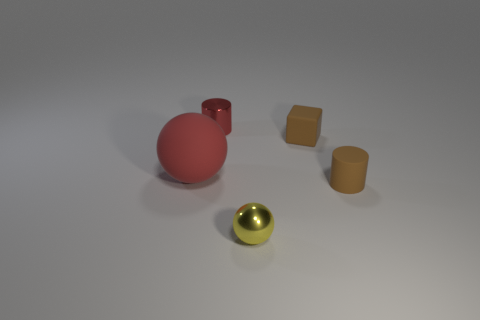Do the brown cylinder and the yellow sphere have the same size?
Offer a very short reply. Yes. There is a small brown thing that is the same shape as the red shiny thing; what material is it?
Keep it short and to the point. Rubber. There is a cylinder on the left side of the yellow sphere; is its size the same as the small yellow thing?
Provide a succinct answer. Yes. How many metallic things are either green cubes or small cylinders?
Provide a succinct answer. 1. There is a thing that is on the right side of the metallic sphere and behind the matte cylinder; what is its material?
Provide a succinct answer. Rubber. Is the material of the yellow thing the same as the big red thing?
Your answer should be compact. No. How big is the thing that is left of the block and behind the red rubber sphere?
Your answer should be very brief. Small. What is the shape of the red metallic thing?
Provide a succinct answer. Cylinder. How many objects are either blue objects or brown rubber things that are behind the big sphere?
Your answer should be very brief. 1. There is a sphere on the right side of the red rubber sphere; is its color the same as the rubber ball?
Give a very brief answer. No. 